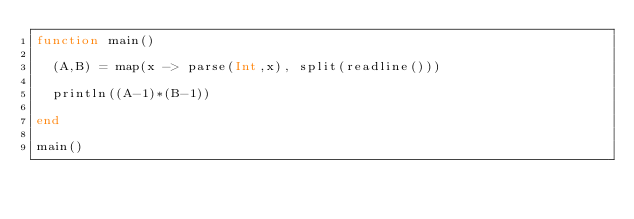Convert code to text. <code><loc_0><loc_0><loc_500><loc_500><_Julia_>function main()
  
  (A,B) = map(x -> parse(Int,x), split(readline()))
  
  println((A-1)*(B-1))
  
end

main()</code> 